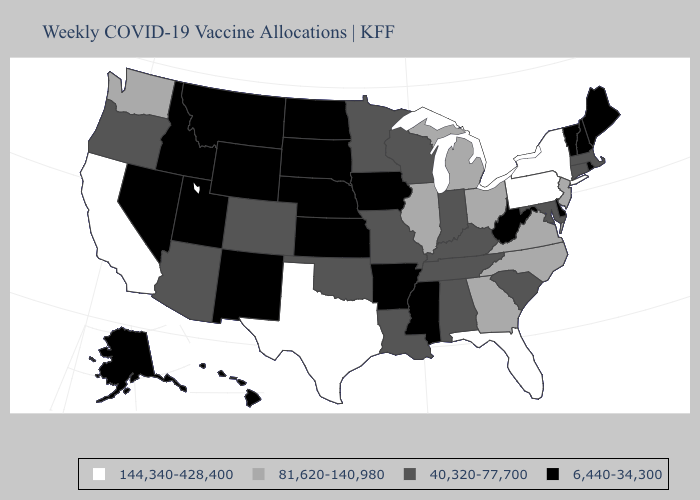What is the value of Pennsylvania?
Keep it brief. 144,340-428,400. What is the lowest value in states that border New Jersey?
Answer briefly. 6,440-34,300. Name the states that have a value in the range 81,620-140,980?
Be succinct. Georgia, Illinois, Michigan, New Jersey, North Carolina, Ohio, Virginia, Washington. Which states have the lowest value in the USA?
Give a very brief answer. Alaska, Arkansas, Delaware, Hawaii, Idaho, Iowa, Kansas, Maine, Mississippi, Montana, Nebraska, Nevada, New Hampshire, New Mexico, North Dakota, Rhode Island, South Dakota, Utah, Vermont, West Virginia, Wyoming. Name the states that have a value in the range 6,440-34,300?
Concise answer only. Alaska, Arkansas, Delaware, Hawaii, Idaho, Iowa, Kansas, Maine, Mississippi, Montana, Nebraska, Nevada, New Hampshire, New Mexico, North Dakota, Rhode Island, South Dakota, Utah, Vermont, West Virginia, Wyoming. Does Nebraska have the highest value in the USA?
Concise answer only. No. What is the highest value in the USA?
Write a very short answer. 144,340-428,400. Name the states that have a value in the range 40,320-77,700?
Quick response, please. Alabama, Arizona, Colorado, Connecticut, Indiana, Kentucky, Louisiana, Maryland, Massachusetts, Minnesota, Missouri, Oklahoma, Oregon, South Carolina, Tennessee, Wisconsin. Does Maryland have the lowest value in the South?
Answer briefly. No. Among the states that border Wyoming , which have the lowest value?
Concise answer only. Idaho, Montana, Nebraska, South Dakota, Utah. Does the map have missing data?
Quick response, please. No. Does Rhode Island have a higher value than Colorado?
Keep it brief. No. Does the map have missing data?
Answer briefly. No. What is the value of Pennsylvania?
Be succinct. 144,340-428,400. 